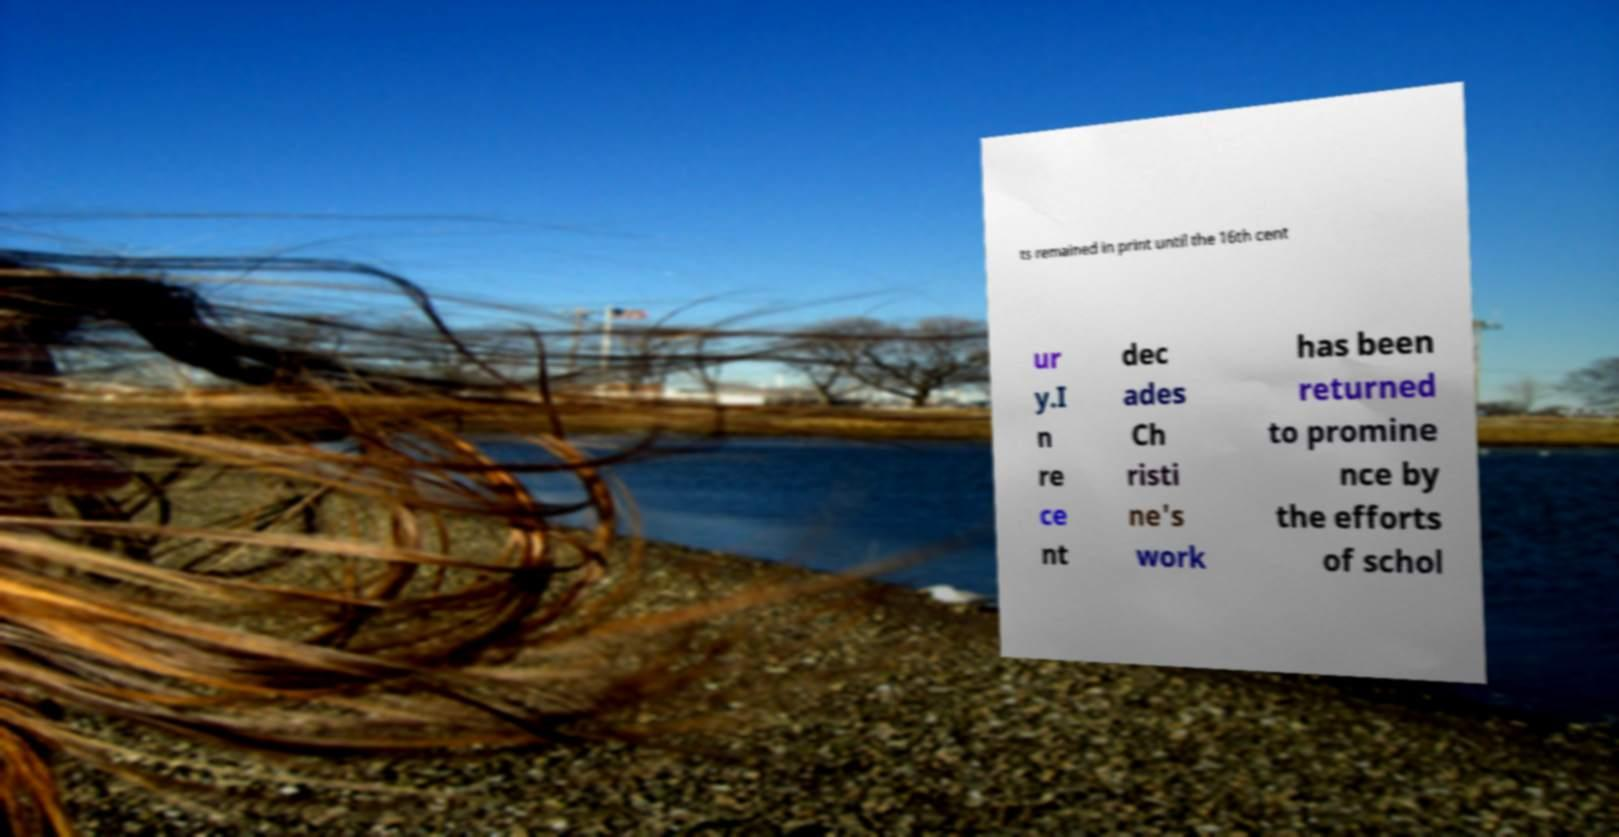Can you accurately transcribe the text from the provided image for me? ts remained in print until the 16th cent ur y.I n re ce nt dec ades Ch risti ne's work has been returned to promine nce by the efforts of schol 